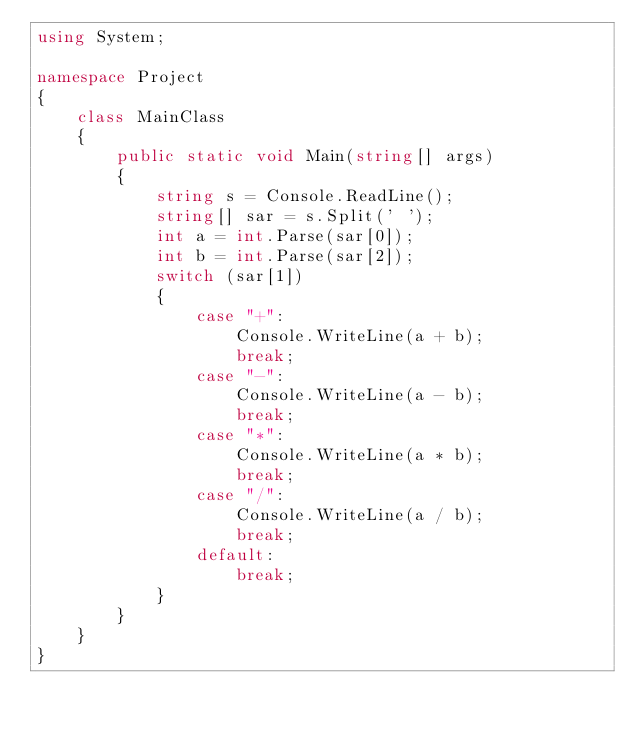Convert code to text. <code><loc_0><loc_0><loc_500><loc_500><_C#_>using System;

namespace Project
{
	class MainClass
	{
		public static void Main(string[] args)
		{
			string s = Console.ReadLine();
			string[] sar = s.Split(' ');
			int a = int.Parse(sar[0]);
			int b = int.Parse(sar[2]);
			switch (sar[1])
			{
				case "+":
					Console.WriteLine(a + b);
					break;
				case "-":
					Console.WriteLine(a - b);
					break;
				case "*":
					Console.WriteLine(a * b);
					break;
				case "/":
					Console.WriteLine(a / b);
					break;
				default:
					break;
			}
		}
	}
}</code> 